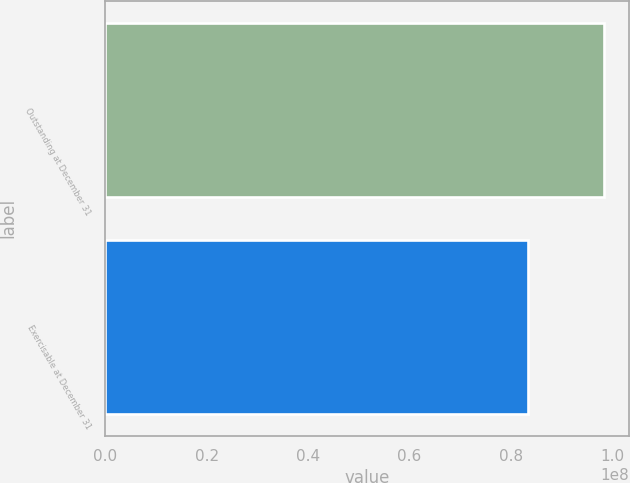Convert chart to OTSL. <chart><loc_0><loc_0><loc_500><loc_500><bar_chart><fcel>Outstanding at December 31<fcel>Exercisable at December 31<nl><fcel>9.8485e+07<fcel>8.3361e+07<nl></chart> 